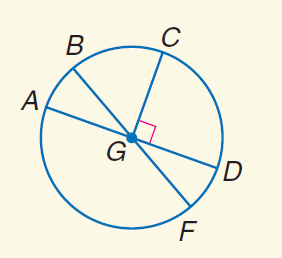Answer the mathemtical geometry problem and directly provide the correct option letter.
Question: In \odot G, m \angle A G B = 30 and C G \perp G D. Find m \widehat C D F.
Choices: A: 30 B: 90 C: 120 D: 150 C 